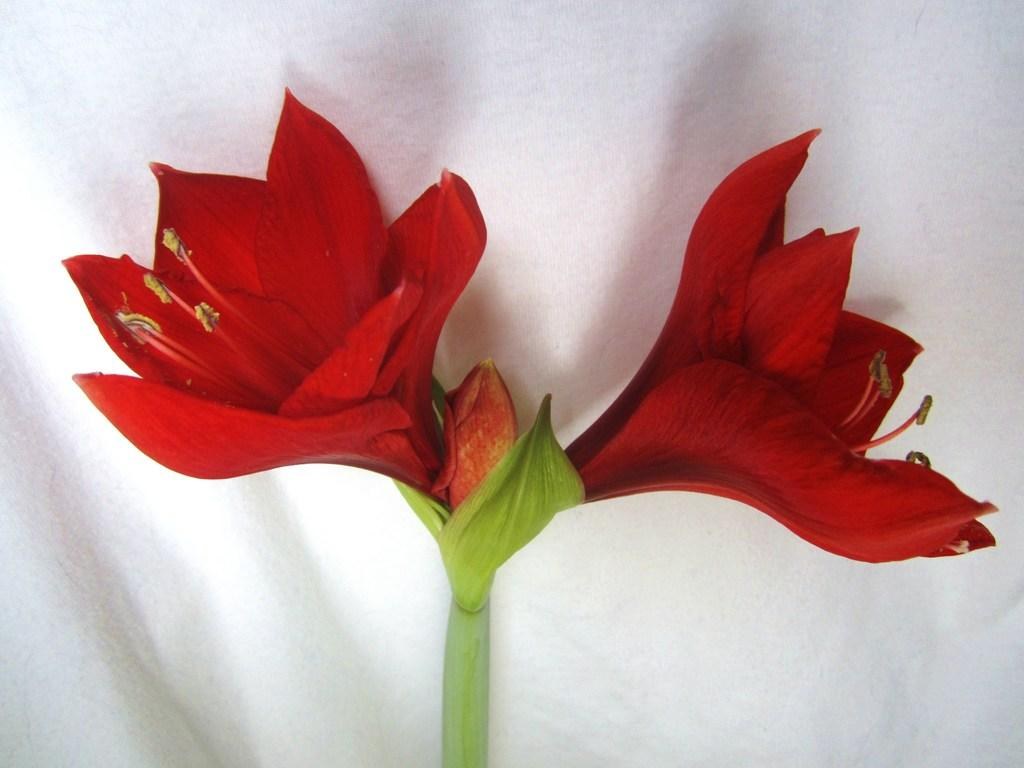What is the main subject of the image? The main subject of the image is a stem with two flowers and a bud. What color are the flowers? The flowers are dark red in color. What can be seen in the background of the image? There is a white surface in the background of the image. What might the white surface be made of? The white surface appears to be a cloth. What type of business is being conducted in the image? There is no indication of any business being conducted in the image; it primarily features a stem with flowers and a bud against a white cloth background. 